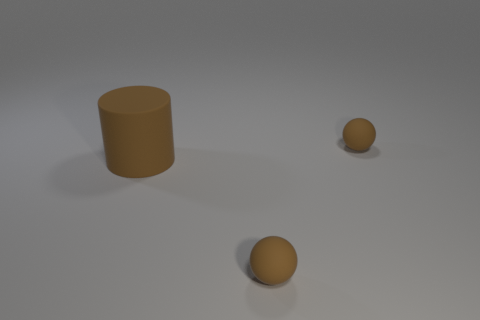Is the shape of the brown thing that is behind the rubber cylinder the same as  the large brown matte thing?
Keep it short and to the point. No. Is there any other thing that is made of the same material as the large brown cylinder?
Give a very brief answer. Yes. There is a brown cylinder; does it have the same size as the thing in front of the large rubber cylinder?
Your answer should be compact. No. How many other things are the same color as the big cylinder?
Make the answer very short. 2. Are there any big matte cylinders behind the rubber cylinder?
Ensure brevity in your answer.  No. How many objects are big brown matte cylinders or brown rubber objects that are in front of the big cylinder?
Ensure brevity in your answer.  2. Are there any matte spheres on the left side of the small brown matte sphere behind the big cylinder?
Offer a very short reply. Yes. The small rubber thing to the left of the small matte thing on the right side of the small rubber ball that is in front of the large brown rubber cylinder is what shape?
Provide a succinct answer. Sphere. There is a tiny object that is behind the big cylinder; what shape is it?
Offer a very short reply. Sphere. What number of matte things are brown balls or big cylinders?
Keep it short and to the point. 3. 